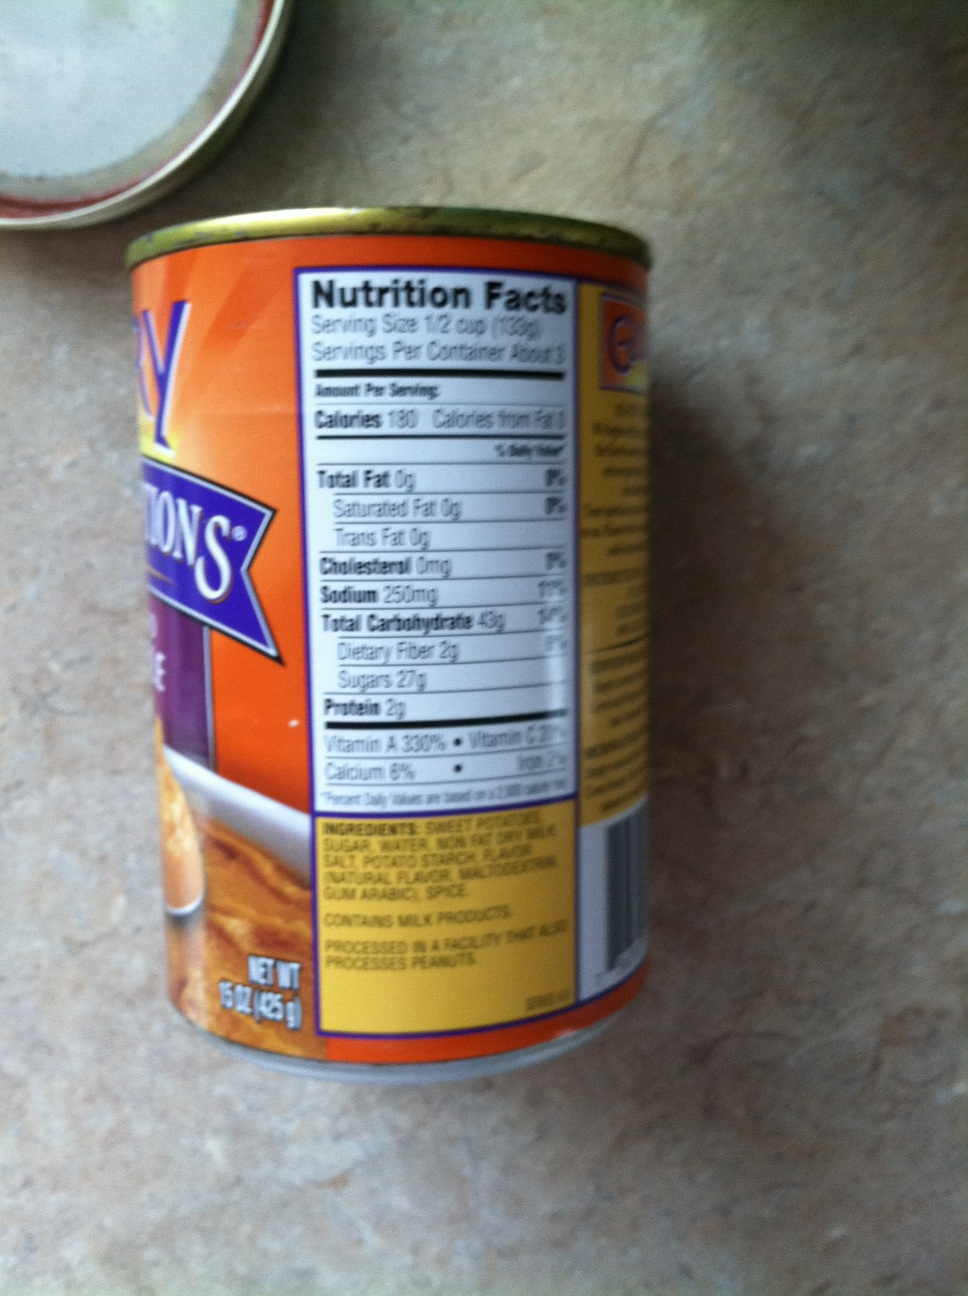What kind of item do you think is inside this tin? Based on the label, this tin contains sweet potatoes. The ingredients list includes sweet potatoes, sugar, and spices, which suggests that it might be a canned sweet potato dish. 